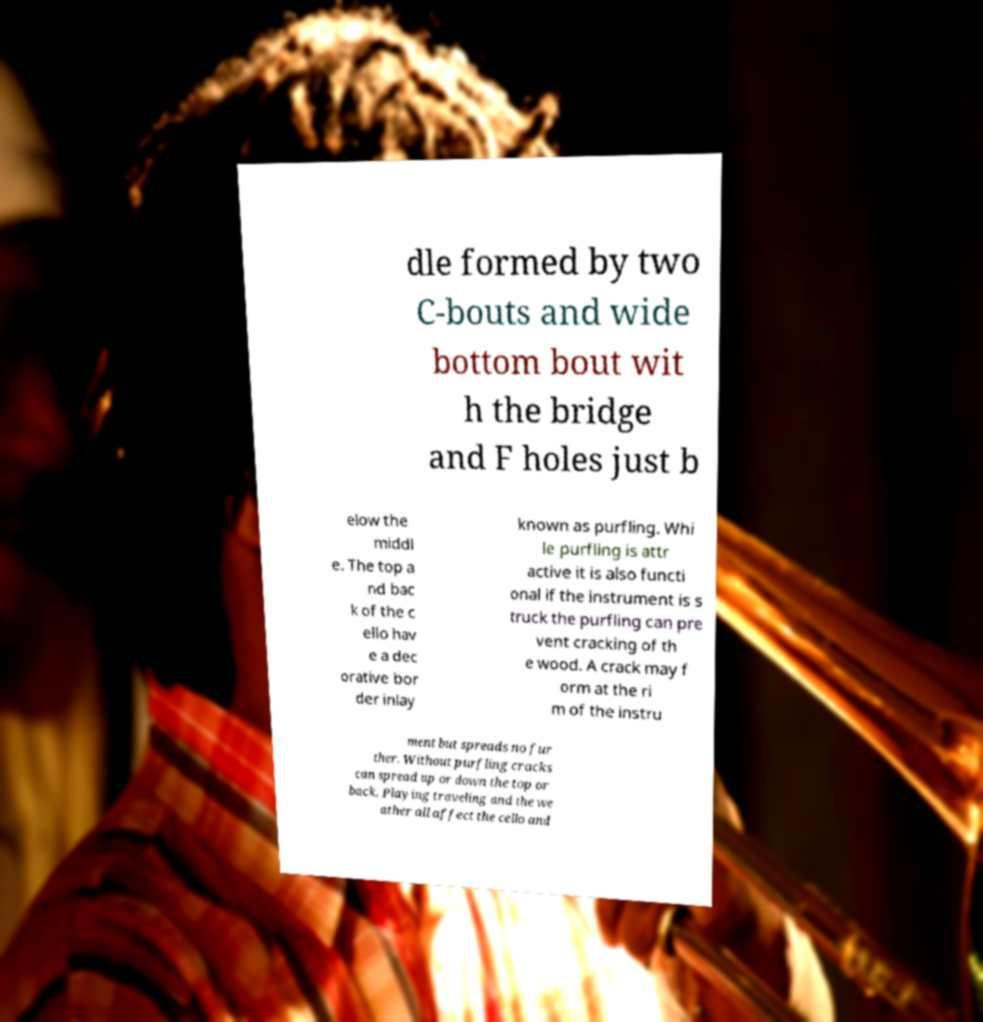Could you extract and type out the text from this image? dle formed by two C-bouts and wide bottom bout wit h the bridge and F holes just b elow the middl e. The top a nd bac k of the c ello hav e a dec orative bor der inlay known as purfling. Whi le purfling is attr active it is also functi onal if the instrument is s truck the purfling can pre vent cracking of th e wood. A crack may f orm at the ri m of the instru ment but spreads no fur ther. Without purfling cracks can spread up or down the top or back. Playing traveling and the we ather all affect the cello and 